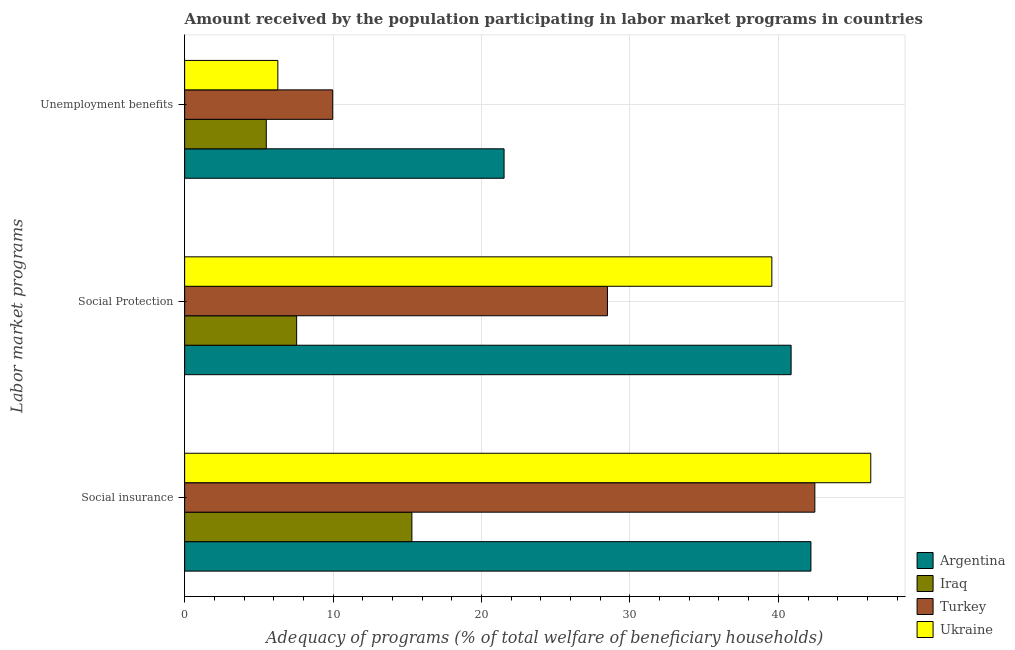How many different coloured bars are there?
Your answer should be very brief. 4. How many groups of bars are there?
Your answer should be compact. 3. How many bars are there on the 2nd tick from the top?
Keep it short and to the point. 4. What is the label of the 2nd group of bars from the top?
Keep it short and to the point. Social Protection. What is the amount received by the population participating in social protection programs in Ukraine?
Provide a short and direct response. 39.56. Across all countries, what is the maximum amount received by the population participating in social protection programs?
Ensure brevity in your answer.  40.86. Across all countries, what is the minimum amount received by the population participating in unemployment benefits programs?
Ensure brevity in your answer.  5.5. In which country was the amount received by the population participating in unemployment benefits programs maximum?
Provide a short and direct response. Argentina. In which country was the amount received by the population participating in unemployment benefits programs minimum?
Ensure brevity in your answer.  Iraq. What is the total amount received by the population participating in social protection programs in the graph?
Provide a short and direct response. 116.45. What is the difference between the amount received by the population participating in social insurance programs in Turkey and that in Ukraine?
Give a very brief answer. -3.77. What is the difference between the amount received by the population participating in social insurance programs in Iraq and the amount received by the population participating in unemployment benefits programs in Turkey?
Offer a very short reply. 5.33. What is the average amount received by the population participating in unemployment benefits programs per country?
Provide a succinct answer. 10.82. What is the difference between the amount received by the population participating in unemployment benefits programs and amount received by the population participating in social insurance programs in Turkey?
Provide a succinct answer. -32.48. In how many countries, is the amount received by the population participating in unemployment benefits programs greater than 2 %?
Your answer should be compact. 4. What is the ratio of the amount received by the population participating in social protection programs in Iraq to that in Turkey?
Your response must be concise. 0.26. Is the amount received by the population participating in social protection programs in Argentina less than that in Ukraine?
Your answer should be compact. No. Is the difference between the amount received by the population participating in social insurance programs in Turkey and Argentina greater than the difference between the amount received by the population participating in unemployment benefits programs in Turkey and Argentina?
Offer a terse response. Yes. What is the difference between the highest and the second highest amount received by the population participating in social insurance programs?
Offer a very short reply. 3.77. What is the difference between the highest and the lowest amount received by the population participating in unemployment benefits programs?
Your answer should be compact. 16.02. In how many countries, is the amount received by the population participating in social protection programs greater than the average amount received by the population participating in social protection programs taken over all countries?
Make the answer very short. 2. What does the 2nd bar from the top in Unemployment benefits represents?
Your answer should be compact. Turkey. What does the 2nd bar from the bottom in Social insurance represents?
Ensure brevity in your answer.  Iraq. Is it the case that in every country, the sum of the amount received by the population participating in social insurance programs and amount received by the population participating in social protection programs is greater than the amount received by the population participating in unemployment benefits programs?
Keep it short and to the point. Yes. How many bars are there?
Your response must be concise. 12. Are all the bars in the graph horizontal?
Your response must be concise. Yes. How many countries are there in the graph?
Your answer should be compact. 4. What is the difference between two consecutive major ticks on the X-axis?
Make the answer very short. 10. Are the values on the major ticks of X-axis written in scientific E-notation?
Give a very brief answer. No. Does the graph contain any zero values?
Provide a short and direct response. No. How many legend labels are there?
Ensure brevity in your answer.  4. How are the legend labels stacked?
Ensure brevity in your answer.  Vertical. What is the title of the graph?
Your answer should be very brief. Amount received by the population participating in labor market programs in countries. What is the label or title of the X-axis?
Your answer should be very brief. Adequacy of programs (% of total welfare of beneficiary households). What is the label or title of the Y-axis?
Keep it short and to the point. Labor market programs. What is the Adequacy of programs (% of total welfare of beneficiary households) of Argentina in Social insurance?
Offer a terse response. 42.2. What is the Adequacy of programs (% of total welfare of beneficiary households) of Iraq in Social insurance?
Give a very brief answer. 15.31. What is the Adequacy of programs (% of total welfare of beneficiary households) in Turkey in Social insurance?
Give a very brief answer. 42.46. What is the Adequacy of programs (% of total welfare of beneficiary households) of Ukraine in Social insurance?
Ensure brevity in your answer.  46.23. What is the Adequacy of programs (% of total welfare of beneficiary households) of Argentina in Social Protection?
Your answer should be very brief. 40.86. What is the Adequacy of programs (% of total welfare of beneficiary households) in Iraq in Social Protection?
Provide a succinct answer. 7.55. What is the Adequacy of programs (% of total welfare of beneficiary households) of Turkey in Social Protection?
Ensure brevity in your answer.  28.49. What is the Adequacy of programs (% of total welfare of beneficiary households) in Ukraine in Social Protection?
Give a very brief answer. 39.56. What is the Adequacy of programs (% of total welfare of beneficiary households) in Argentina in Unemployment benefits?
Ensure brevity in your answer.  21.52. What is the Adequacy of programs (% of total welfare of beneficiary households) in Iraq in Unemployment benefits?
Provide a succinct answer. 5.5. What is the Adequacy of programs (% of total welfare of beneficiary households) in Turkey in Unemployment benefits?
Your answer should be very brief. 9.98. What is the Adequacy of programs (% of total welfare of beneficiary households) in Ukraine in Unemployment benefits?
Your answer should be very brief. 6.28. Across all Labor market programs, what is the maximum Adequacy of programs (% of total welfare of beneficiary households) in Argentina?
Make the answer very short. 42.2. Across all Labor market programs, what is the maximum Adequacy of programs (% of total welfare of beneficiary households) of Iraq?
Ensure brevity in your answer.  15.31. Across all Labor market programs, what is the maximum Adequacy of programs (% of total welfare of beneficiary households) of Turkey?
Offer a very short reply. 42.46. Across all Labor market programs, what is the maximum Adequacy of programs (% of total welfare of beneficiary households) in Ukraine?
Offer a very short reply. 46.23. Across all Labor market programs, what is the minimum Adequacy of programs (% of total welfare of beneficiary households) in Argentina?
Your answer should be very brief. 21.52. Across all Labor market programs, what is the minimum Adequacy of programs (% of total welfare of beneficiary households) of Iraq?
Make the answer very short. 5.5. Across all Labor market programs, what is the minimum Adequacy of programs (% of total welfare of beneficiary households) in Turkey?
Your answer should be very brief. 9.98. Across all Labor market programs, what is the minimum Adequacy of programs (% of total welfare of beneficiary households) in Ukraine?
Provide a short and direct response. 6.28. What is the total Adequacy of programs (% of total welfare of beneficiary households) of Argentina in the graph?
Provide a succinct answer. 104.58. What is the total Adequacy of programs (% of total welfare of beneficiary households) of Iraq in the graph?
Offer a terse response. 28.36. What is the total Adequacy of programs (% of total welfare of beneficiary households) of Turkey in the graph?
Your response must be concise. 80.92. What is the total Adequacy of programs (% of total welfare of beneficiary households) in Ukraine in the graph?
Provide a short and direct response. 92.07. What is the difference between the Adequacy of programs (% of total welfare of beneficiary households) of Argentina in Social insurance and that in Social Protection?
Make the answer very short. 1.33. What is the difference between the Adequacy of programs (% of total welfare of beneficiary households) in Iraq in Social insurance and that in Social Protection?
Your answer should be very brief. 7.77. What is the difference between the Adequacy of programs (% of total welfare of beneficiary households) of Turkey in Social insurance and that in Social Protection?
Offer a very short reply. 13.97. What is the difference between the Adequacy of programs (% of total welfare of beneficiary households) in Ukraine in Social insurance and that in Social Protection?
Give a very brief answer. 6.66. What is the difference between the Adequacy of programs (% of total welfare of beneficiary households) in Argentina in Social insurance and that in Unemployment benefits?
Your answer should be very brief. 20.67. What is the difference between the Adequacy of programs (% of total welfare of beneficiary households) of Iraq in Social insurance and that in Unemployment benefits?
Your answer should be compact. 9.81. What is the difference between the Adequacy of programs (% of total welfare of beneficiary households) of Turkey in Social insurance and that in Unemployment benefits?
Offer a terse response. 32.48. What is the difference between the Adequacy of programs (% of total welfare of beneficiary households) in Ukraine in Social insurance and that in Unemployment benefits?
Your response must be concise. 39.95. What is the difference between the Adequacy of programs (% of total welfare of beneficiary households) in Argentina in Social Protection and that in Unemployment benefits?
Your response must be concise. 19.34. What is the difference between the Adequacy of programs (% of total welfare of beneficiary households) of Iraq in Social Protection and that in Unemployment benefits?
Provide a succinct answer. 2.05. What is the difference between the Adequacy of programs (% of total welfare of beneficiary households) of Turkey in Social Protection and that in Unemployment benefits?
Ensure brevity in your answer.  18.51. What is the difference between the Adequacy of programs (% of total welfare of beneficiary households) of Ukraine in Social Protection and that in Unemployment benefits?
Keep it short and to the point. 33.28. What is the difference between the Adequacy of programs (% of total welfare of beneficiary households) of Argentina in Social insurance and the Adequacy of programs (% of total welfare of beneficiary households) of Iraq in Social Protection?
Provide a short and direct response. 34.65. What is the difference between the Adequacy of programs (% of total welfare of beneficiary households) in Argentina in Social insurance and the Adequacy of programs (% of total welfare of beneficiary households) in Turkey in Social Protection?
Keep it short and to the point. 13.71. What is the difference between the Adequacy of programs (% of total welfare of beneficiary households) in Argentina in Social insurance and the Adequacy of programs (% of total welfare of beneficiary households) in Ukraine in Social Protection?
Offer a terse response. 2.63. What is the difference between the Adequacy of programs (% of total welfare of beneficiary households) in Iraq in Social insurance and the Adequacy of programs (% of total welfare of beneficiary households) in Turkey in Social Protection?
Offer a terse response. -13.17. What is the difference between the Adequacy of programs (% of total welfare of beneficiary households) in Iraq in Social insurance and the Adequacy of programs (% of total welfare of beneficiary households) in Ukraine in Social Protection?
Your response must be concise. -24.25. What is the difference between the Adequacy of programs (% of total welfare of beneficiary households) in Turkey in Social insurance and the Adequacy of programs (% of total welfare of beneficiary households) in Ukraine in Social Protection?
Keep it short and to the point. 2.9. What is the difference between the Adequacy of programs (% of total welfare of beneficiary households) in Argentina in Social insurance and the Adequacy of programs (% of total welfare of beneficiary households) in Iraq in Unemployment benefits?
Make the answer very short. 36.69. What is the difference between the Adequacy of programs (% of total welfare of beneficiary households) in Argentina in Social insurance and the Adequacy of programs (% of total welfare of beneficiary households) in Turkey in Unemployment benefits?
Provide a short and direct response. 32.22. What is the difference between the Adequacy of programs (% of total welfare of beneficiary households) of Argentina in Social insurance and the Adequacy of programs (% of total welfare of beneficiary households) of Ukraine in Unemployment benefits?
Keep it short and to the point. 35.92. What is the difference between the Adequacy of programs (% of total welfare of beneficiary households) of Iraq in Social insurance and the Adequacy of programs (% of total welfare of beneficiary households) of Turkey in Unemployment benefits?
Offer a very short reply. 5.33. What is the difference between the Adequacy of programs (% of total welfare of beneficiary households) of Iraq in Social insurance and the Adequacy of programs (% of total welfare of beneficiary households) of Ukraine in Unemployment benefits?
Ensure brevity in your answer.  9.03. What is the difference between the Adequacy of programs (% of total welfare of beneficiary households) of Turkey in Social insurance and the Adequacy of programs (% of total welfare of beneficiary households) of Ukraine in Unemployment benefits?
Provide a short and direct response. 36.18. What is the difference between the Adequacy of programs (% of total welfare of beneficiary households) in Argentina in Social Protection and the Adequacy of programs (% of total welfare of beneficiary households) in Iraq in Unemployment benefits?
Give a very brief answer. 35.36. What is the difference between the Adequacy of programs (% of total welfare of beneficiary households) in Argentina in Social Protection and the Adequacy of programs (% of total welfare of beneficiary households) in Turkey in Unemployment benefits?
Your answer should be compact. 30.88. What is the difference between the Adequacy of programs (% of total welfare of beneficiary households) in Argentina in Social Protection and the Adequacy of programs (% of total welfare of beneficiary households) in Ukraine in Unemployment benefits?
Offer a very short reply. 34.58. What is the difference between the Adequacy of programs (% of total welfare of beneficiary households) of Iraq in Social Protection and the Adequacy of programs (% of total welfare of beneficiary households) of Turkey in Unemployment benefits?
Keep it short and to the point. -2.43. What is the difference between the Adequacy of programs (% of total welfare of beneficiary households) of Iraq in Social Protection and the Adequacy of programs (% of total welfare of beneficiary households) of Ukraine in Unemployment benefits?
Your answer should be compact. 1.27. What is the difference between the Adequacy of programs (% of total welfare of beneficiary households) of Turkey in Social Protection and the Adequacy of programs (% of total welfare of beneficiary households) of Ukraine in Unemployment benefits?
Offer a very short reply. 22.21. What is the average Adequacy of programs (% of total welfare of beneficiary households) of Argentina per Labor market programs?
Keep it short and to the point. 34.86. What is the average Adequacy of programs (% of total welfare of beneficiary households) in Iraq per Labor market programs?
Your answer should be compact. 9.45. What is the average Adequacy of programs (% of total welfare of beneficiary households) of Turkey per Labor market programs?
Give a very brief answer. 26.97. What is the average Adequacy of programs (% of total welfare of beneficiary households) of Ukraine per Labor market programs?
Offer a very short reply. 30.69. What is the difference between the Adequacy of programs (% of total welfare of beneficiary households) of Argentina and Adequacy of programs (% of total welfare of beneficiary households) of Iraq in Social insurance?
Your answer should be compact. 26.88. What is the difference between the Adequacy of programs (% of total welfare of beneficiary households) of Argentina and Adequacy of programs (% of total welfare of beneficiary households) of Turkey in Social insurance?
Give a very brief answer. -0.26. What is the difference between the Adequacy of programs (% of total welfare of beneficiary households) in Argentina and Adequacy of programs (% of total welfare of beneficiary households) in Ukraine in Social insurance?
Provide a succinct answer. -4.03. What is the difference between the Adequacy of programs (% of total welfare of beneficiary households) in Iraq and Adequacy of programs (% of total welfare of beneficiary households) in Turkey in Social insurance?
Provide a succinct answer. -27.15. What is the difference between the Adequacy of programs (% of total welfare of beneficiary households) of Iraq and Adequacy of programs (% of total welfare of beneficiary households) of Ukraine in Social insurance?
Ensure brevity in your answer.  -30.92. What is the difference between the Adequacy of programs (% of total welfare of beneficiary households) in Turkey and Adequacy of programs (% of total welfare of beneficiary households) in Ukraine in Social insurance?
Your answer should be compact. -3.77. What is the difference between the Adequacy of programs (% of total welfare of beneficiary households) of Argentina and Adequacy of programs (% of total welfare of beneficiary households) of Iraq in Social Protection?
Your answer should be compact. 33.31. What is the difference between the Adequacy of programs (% of total welfare of beneficiary households) of Argentina and Adequacy of programs (% of total welfare of beneficiary households) of Turkey in Social Protection?
Offer a terse response. 12.37. What is the difference between the Adequacy of programs (% of total welfare of beneficiary households) in Argentina and Adequacy of programs (% of total welfare of beneficiary households) in Ukraine in Social Protection?
Keep it short and to the point. 1.3. What is the difference between the Adequacy of programs (% of total welfare of beneficiary households) of Iraq and Adequacy of programs (% of total welfare of beneficiary households) of Turkey in Social Protection?
Offer a very short reply. -20.94. What is the difference between the Adequacy of programs (% of total welfare of beneficiary households) of Iraq and Adequacy of programs (% of total welfare of beneficiary households) of Ukraine in Social Protection?
Ensure brevity in your answer.  -32.02. What is the difference between the Adequacy of programs (% of total welfare of beneficiary households) of Turkey and Adequacy of programs (% of total welfare of beneficiary households) of Ukraine in Social Protection?
Provide a short and direct response. -11.08. What is the difference between the Adequacy of programs (% of total welfare of beneficiary households) of Argentina and Adequacy of programs (% of total welfare of beneficiary households) of Iraq in Unemployment benefits?
Keep it short and to the point. 16.02. What is the difference between the Adequacy of programs (% of total welfare of beneficiary households) of Argentina and Adequacy of programs (% of total welfare of beneficiary households) of Turkey in Unemployment benefits?
Make the answer very short. 11.54. What is the difference between the Adequacy of programs (% of total welfare of beneficiary households) in Argentina and Adequacy of programs (% of total welfare of beneficiary households) in Ukraine in Unemployment benefits?
Your answer should be compact. 15.24. What is the difference between the Adequacy of programs (% of total welfare of beneficiary households) of Iraq and Adequacy of programs (% of total welfare of beneficiary households) of Turkey in Unemployment benefits?
Provide a short and direct response. -4.48. What is the difference between the Adequacy of programs (% of total welfare of beneficiary households) in Iraq and Adequacy of programs (% of total welfare of beneficiary households) in Ukraine in Unemployment benefits?
Keep it short and to the point. -0.78. What is the difference between the Adequacy of programs (% of total welfare of beneficiary households) in Turkey and Adequacy of programs (% of total welfare of beneficiary households) in Ukraine in Unemployment benefits?
Ensure brevity in your answer.  3.7. What is the ratio of the Adequacy of programs (% of total welfare of beneficiary households) of Argentina in Social insurance to that in Social Protection?
Provide a short and direct response. 1.03. What is the ratio of the Adequacy of programs (% of total welfare of beneficiary households) in Iraq in Social insurance to that in Social Protection?
Provide a short and direct response. 2.03. What is the ratio of the Adequacy of programs (% of total welfare of beneficiary households) of Turkey in Social insurance to that in Social Protection?
Offer a very short reply. 1.49. What is the ratio of the Adequacy of programs (% of total welfare of beneficiary households) in Ukraine in Social insurance to that in Social Protection?
Offer a terse response. 1.17. What is the ratio of the Adequacy of programs (% of total welfare of beneficiary households) in Argentina in Social insurance to that in Unemployment benefits?
Ensure brevity in your answer.  1.96. What is the ratio of the Adequacy of programs (% of total welfare of beneficiary households) in Iraq in Social insurance to that in Unemployment benefits?
Your answer should be compact. 2.78. What is the ratio of the Adequacy of programs (% of total welfare of beneficiary households) of Turkey in Social insurance to that in Unemployment benefits?
Your response must be concise. 4.26. What is the ratio of the Adequacy of programs (% of total welfare of beneficiary households) of Ukraine in Social insurance to that in Unemployment benefits?
Keep it short and to the point. 7.36. What is the ratio of the Adequacy of programs (% of total welfare of beneficiary households) of Argentina in Social Protection to that in Unemployment benefits?
Your answer should be compact. 1.9. What is the ratio of the Adequacy of programs (% of total welfare of beneficiary households) of Iraq in Social Protection to that in Unemployment benefits?
Give a very brief answer. 1.37. What is the ratio of the Adequacy of programs (% of total welfare of beneficiary households) in Turkey in Social Protection to that in Unemployment benefits?
Ensure brevity in your answer.  2.86. What is the ratio of the Adequacy of programs (% of total welfare of beneficiary households) of Ukraine in Social Protection to that in Unemployment benefits?
Keep it short and to the point. 6.3. What is the difference between the highest and the second highest Adequacy of programs (% of total welfare of beneficiary households) in Argentina?
Your answer should be very brief. 1.33. What is the difference between the highest and the second highest Adequacy of programs (% of total welfare of beneficiary households) of Iraq?
Your response must be concise. 7.77. What is the difference between the highest and the second highest Adequacy of programs (% of total welfare of beneficiary households) of Turkey?
Provide a short and direct response. 13.97. What is the difference between the highest and the second highest Adequacy of programs (% of total welfare of beneficiary households) of Ukraine?
Make the answer very short. 6.66. What is the difference between the highest and the lowest Adequacy of programs (% of total welfare of beneficiary households) of Argentina?
Offer a very short reply. 20.67. What is the difference between the highest and the lowest Adequacy of programs (% of total welfare of beneficiary households) in Iraq?
Provide a succinct answer. 9.81. What is the difference between the highest and the lowest Adequacy of programs (% of total welfare of beneficiary households) of Turkey?
Keep it short and to the point. 32.48. What is the difference between the highest and the lowest Adequacy of programs (% of total welfare of beneficiary households) of Ukraine?
Provide a short and direct response. 39.95. 